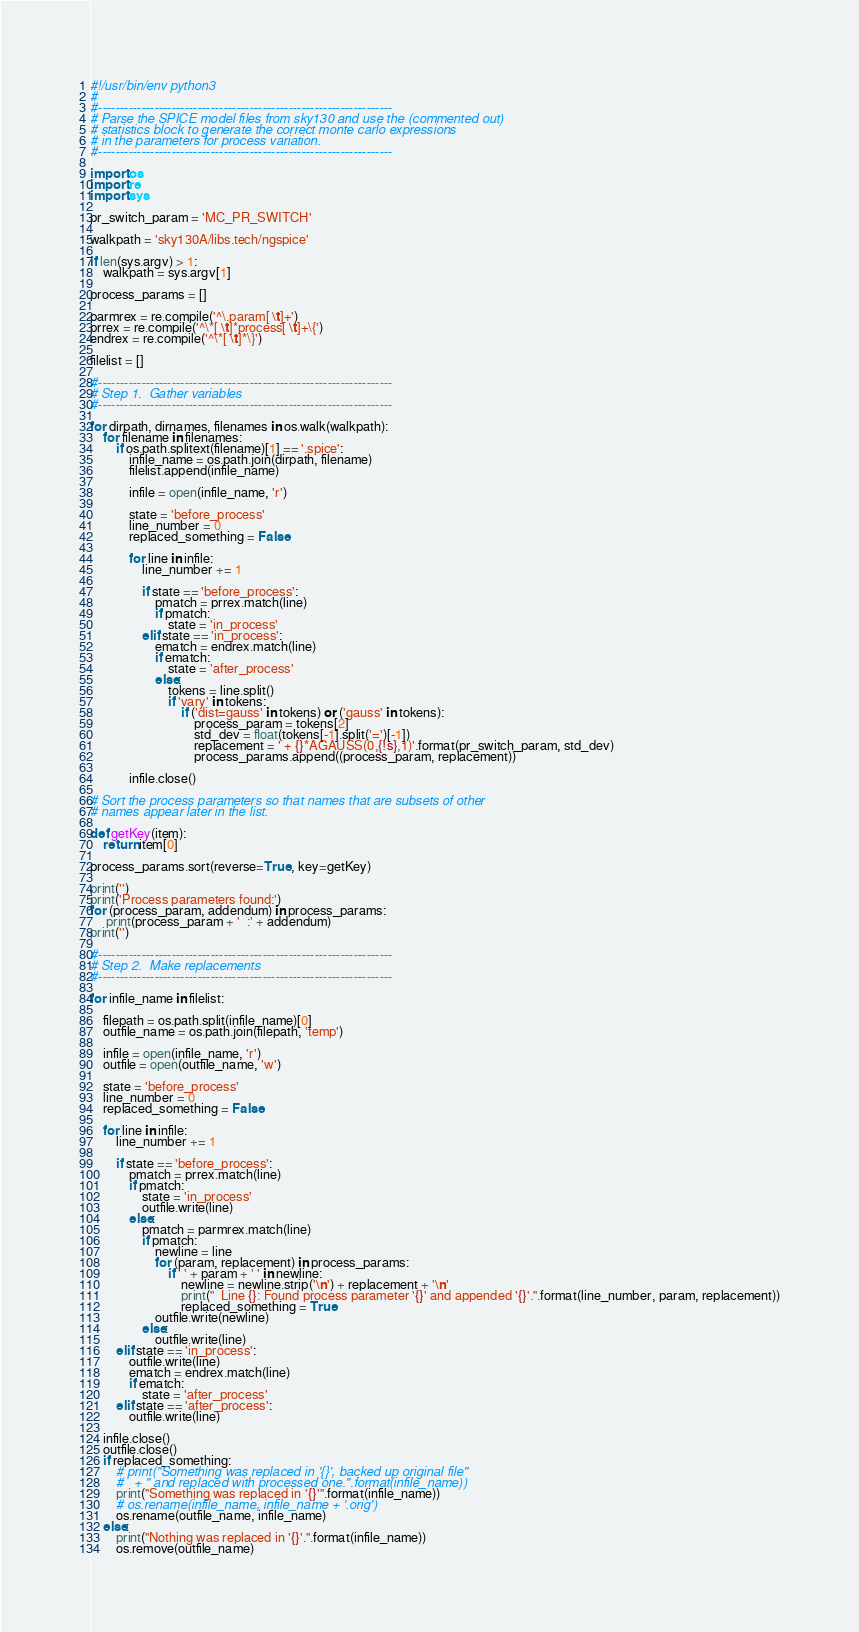Convert code to text. <code><loc_0><loc_0><loc_500><loc_500><_Python_>#!/usr/bin/env python3
#
#--------------------------------------------------------------------
# Parse the SPICE model files from sky130 and use the (commented out)
# statistics block to generate the correct monte carlo expressions
# in the parameters for process variation.
#--------------------------------------------------------------------

import os
import re
import sys

pr_switch_param = 'MC_PR_SWITCH'

walkpath = 'sky130A/libs.tech/ngspice'

if len(sys.argv) > 1:
    walkpath = sys.argv[1]

process_params = []

parmrex = re.compile('^\.param[ \t]+')
prrex = re.compile('^\*[ \t]*process[ \t]+\{')
endrex = re.compile('^\*[ \t]*\}')

filelist = []

#--------------------------------------------------------------------
# Step 1.  Gather variables
#--------------------------------------------------------------------

for dirpath, dirnames, filenames in os.walk(walkpath):
    for filename in filenames:
        if os.path.splitext(filename)[1] == '.spice':
            infile_name = os.path.join(dirpath, filename)
            filelist.append(infile_name)

            infile = open(infile_name, 'r')

            state = 'before_process'
            line_number = 0
            replaced_something = False

            for line in infile:
                line_number += 1

                if state == 'before_process':
                    pmatch = prrex.match(line)
                    if pmatch:
                        state = 'in_process'
                elif state == 'in_process':
                    ematch = endrex.match(line)
                    if ematch:
                        state = 'after_process'
                    else:
                        tokens = line.split()
                        if 'vary' in tokens:
                            if ('dist=gauss' in tokens) or ('gauss' in tokens):
                                process_param = tokens[2]
                                std_dev = float(tokens[-1].split('=')[-1])
                                replacement = ' + {}*AGAUSS(0,{!s},1)'.format(pr_switch_param, std_dev)
                                process_params.append((process_param, replacement))

            infile.close()

# Sort the process parameters so that names that are subsets of other
# names appear later in the list.

def getKey(item):
    return item[0]

process_params.sort(reverse=True, key=getKey)

print('') 
print('Process parameters found:')
for (process_param, addendum) in process_params:
     print(process_param + '  :' + addendum)
print('') 

#--------------------------------------------------------------------
# Step 2.  Make replacements
#--------------------------------------------------------------------

for infile_name in filelist:

    filepath = os.path.split(infile_name)[0]
    outfile_name = os.path.join(filepath, 'temp')

    infile = open(infile_name, 'r')
    outfile = open(outfile_name, 'w')

    state = 'before_process'
    line_number = 0
    replaced_something = False

    for line in infile:
        line_number += 1

        if state == 'before_process':
            pmatch = prrex.match(line)
            if pmatch:
                state = 'in_process'
                outfile.write(line)
            else:
                pmatch = parmrex.match(line)
                if pmatch:
                    newline = line
                    for (param, replacement) in process_params:
                        if ' ' + param + ' ' in newline:
                            newline = newline.strip('\n') + replacement + '\n'
                            print("  Line {}: Found process parameter '{}' and appended '{}'.".format(line_number, param, replacement))
                            replaced_something = True
                    outfile.write(newline)
                else:
                    outfile.write(line)
        elif state == 'in_process':
            outfile.write(line)
            ematch = endrex.match(line)
            if ematch:
                state = 'after_process'
        elif state == 'after_process':
            outfile.write(line)

    infile.close()
    outfile.close()
    if replaced_something:
        # print("Something was replaced in '{}', backed up original file"
        #	+ " and replaced with processed one.".format(infile_name))
        print("Something was replaced in '{}'".format(infile_name))
        # os.rename(infile_name, infile_name + '.orig')
        os.rename(outfile_name, infile_name)
    else:
        print("Nothing was replaced in '{}'.".format(infile_name))
        os.remove(outfile_name)

</code> 